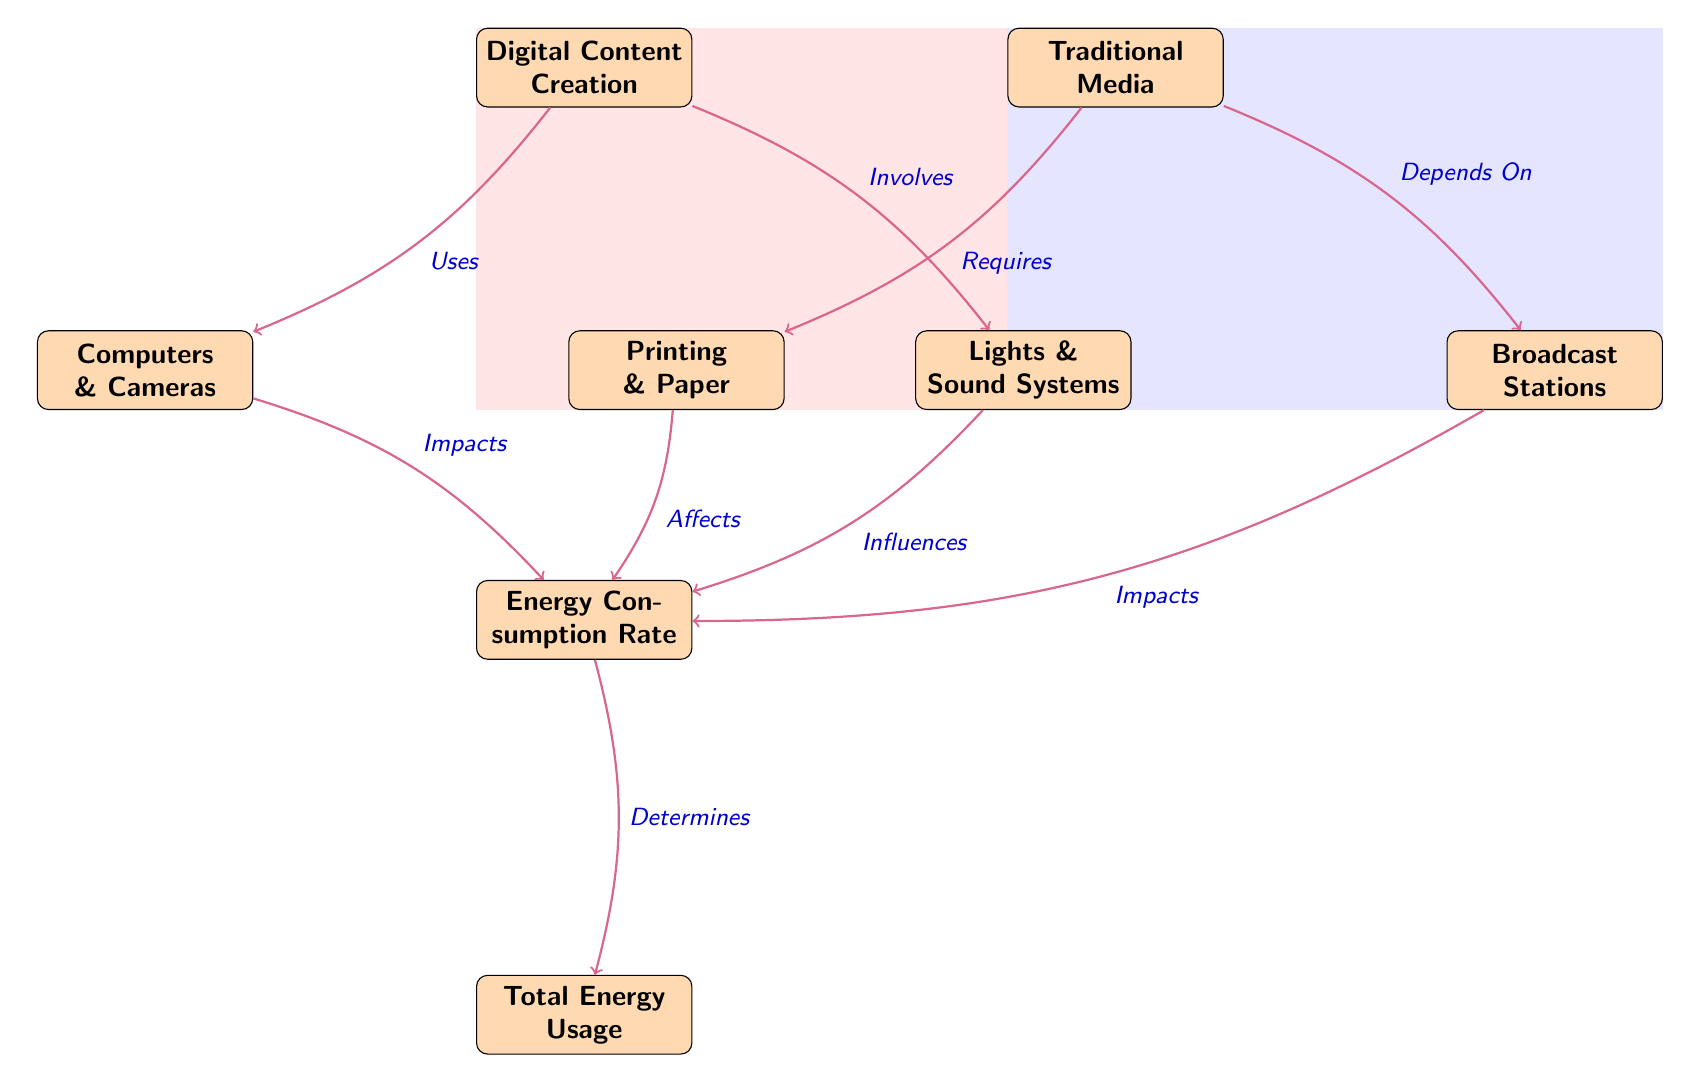What are the two main types of media compared in the diagram? The diagram clearly labels the two main types of media being compared as "Digital Content Creation" and "Traditional Media." These are the top-level categories represented in the diagram.
Answer: Digital Content Creation and Traditional Media How many nodes are in the diagram? By counting each distinct labeled box in the diagram, we find there are a total of six main nodes: Digital Content Creation, Computers & Cameras, Lights & Sound Systems, Traditional Media, Printing & Paper, and Broadcast Stations.
Answer: 6 Which node influences the Energy Consumption Rate aside from Traditional Media? The diagram shows that "Digital Content Creation" is the only node that directly influences the "Energy Consumption Rate" apart from Traditional Media. Therefore, it is also crucial for energy consumption considerations.
Answer: Digital Content Creation What action do Computers & Cameras have in this diagram? The action associated with "Computers & Cameras" is described as "Impacts" the "Energy Consumption Rate." This indicates that the use of computers and cameras is significant enough to affect how much energy is consumed.
Answer: Impacts Which media type involves more energy consumption based on the diagram setup? By analyzing the nodes, both media types are connected to "Energy Consumption Rate," but there is no quantitative comparison given in the diagram itself. However, since Digital Content Creation is focused on technology that typically runs continuously, it suggests a higher energy profile in digital contexts.
Answer: Digital Content Creation What is the relationship between Printing & Paper and the Total Energy Usage? In the diagram, "Printing & Paper" is shown to "Affect" the "Energy Consumption Rate," which in turn "Determines" the "Total Energy Usage." This indicates a cascading influence where the energy consumed in printing affects the overall energy usage.
Answer: Affects Which node is located to the right of Digital Content Creation? According to the layout of the diagram, "Traditional Media" is positioned directly to the right of "Digital Content Creation." This is a clear spatial relationship evident in the diagram's arrangement.
Answer: Traditional Media How many edges connect to the Energy Consumption Rate node? By counting the arrows leading to the "Energy Consumption Rate" node, we can identify four edges: two from "Digital Content Creation" (Computers & Cameras and Lights & Sound Systems) and two from "Traditional Media" (Printing & Paper and Broadcast Stations).
Answer: 4 